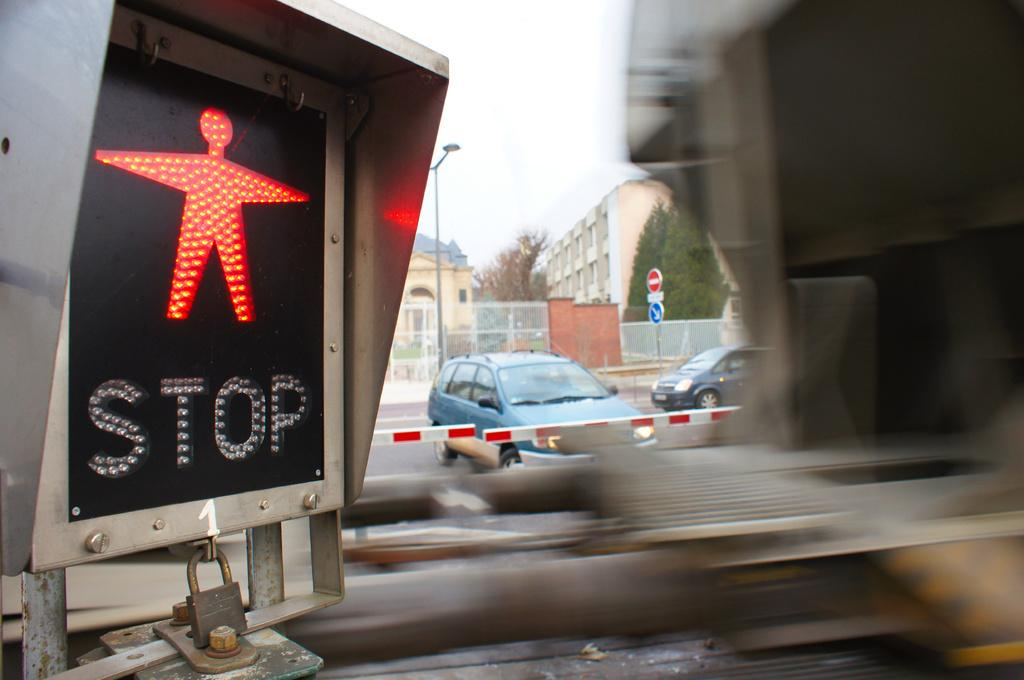<image>
Relay a brief, clear account of the picture shown. Black sign that says the word STOP on it and has a person standing. 